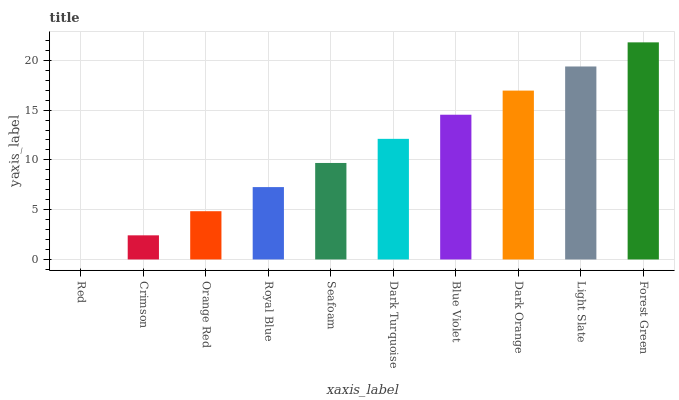Is Red the minimum?
Answer yes or no. Yes. Is Forest Green the maximum?
Answer yes or no. Yes. Is Crimson the minimum?
Answer yes or no. No. Is Crimson the maximum?
Answer yes or no. No. Is Crimson greater than Red?
Answer yes or no. Yes. Is Red less than Crimson?
Answer yes or no. Yes. Is Red greater than Crimson?
Answer yes or no. No. Is Crimson less than Red?
Answer yes or no. No. Is Dark Turquoise the high median?
Answer yes or no. Yes. Is Seafoam the low median?
Answer yes or no. Yes. Is Dark Orange the high median?
Answer yes or no. No. Is Dark Orange the low median?
Answer yes or no. No. 